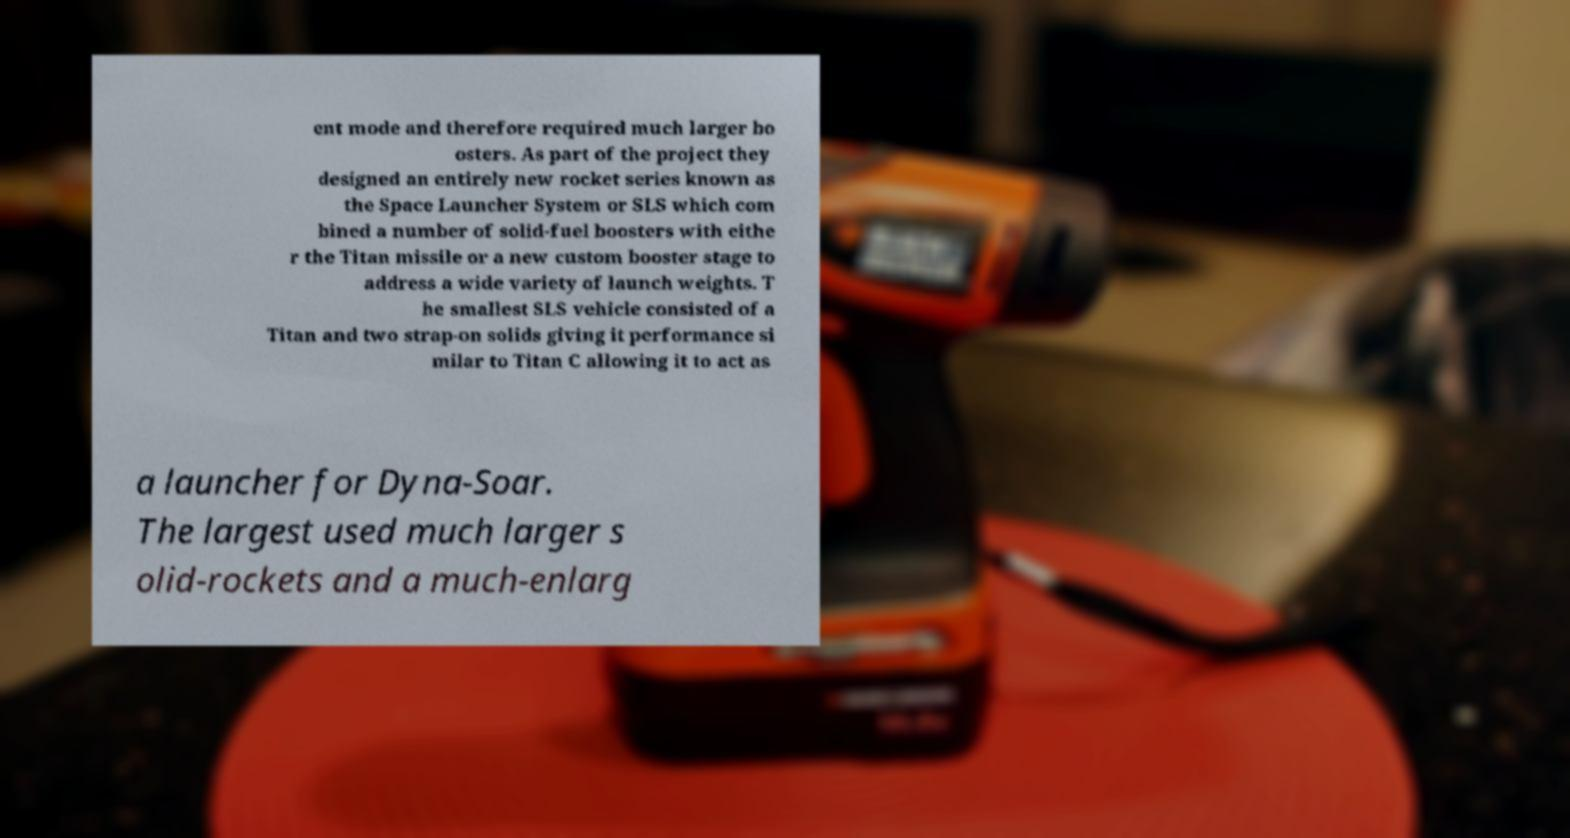Could you extract and type out the text from this image? ent mode and therefore required much larger bo osters. As part of the project they designed an entirely new rocket series known as the Space Launcher System or SLS which com bined a number of solid-fuel boosters with eithe r the Titan missile or a new custom booster stage to address a wide variety of launch weights. T he smallest SLS vehicle consisted of a Titan and two strap-on solids giving it performance si milar to Titan C allowing it to act as a launcher for Dyna-Soar. The largest used much larger s olid-rockets and a much-enlarg 